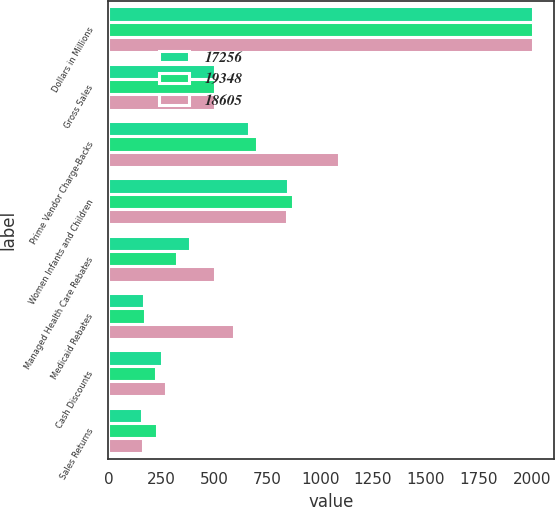Convert chart. <chart><loc_0><loc_0><loc_500><loc_500><stacked_bar_chart><ecel><fcel>Dollars in Millions<fcel>Gross Sales<fcel>Prime Vendor Charge-Backs<fcel>Women Infants and Children<fcel>Managed Health Care Rebates<fcel>Medicaid Rebates<fcel>Cash Discounts<fcel>Sales Returns<nl><fcel>17256<fcel>2007<fcel>502<fcel>662<fcel>848<fcel>387<fcel>169<fcel>251<fcel>160<nl><fcel>19348<fcel>2006<fcel>502<fcel>703<fcel>872<fcel>322<fcel>174<fcel>224<fcel>230<nl><fcel>18605<fcel>2005<fcel>502<fcel>1090<fcel>843<fcel>502<fcel>595<fcel>271<fcel>164<nl></chart> 